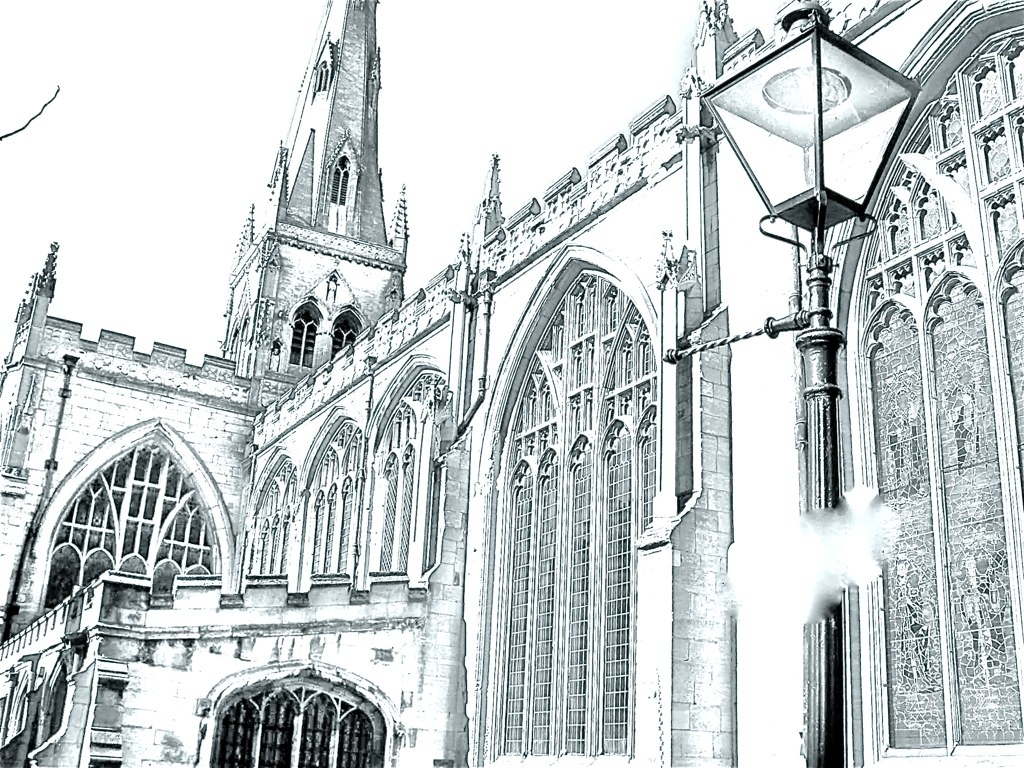What time of day does this photo seem to be taken? The overexposed nature of the photo obscures direct sunlight and shadows, making it difficult to determine the exact time of day. If the image's brightness is due to sunlight, it could suggest the photo was taken around midday when the sun is at its highest point. What impact does the overexposure have on mood or interpretative elements of the picture? The overexposure could be viewed artistically as a method to convey ethereal or otherworldly qualities, often associated with the divine or spiritual aspects of a religious site. It may evoke feelings of transcendence or the sublime, aligning with the enlightening purpose of such a building. 